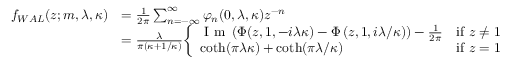Convert formula to latex. <formula><loc_0><loc_0><loc_500><loc_500>{ \begin{array} { r l } { f _ { W A L } ( z ; m , \lambda , \kappa ) } & { = { \frac { 1 } { 2 \pi } } \sum _ { n = - \infty } ^ { \infty } \varphi _ { n } ( 0 , \lambda , \kappa ) z ^ { - n } } \\ & { = { \frac { \lambda } { \pi ( \kappa + 1 / \kappa ) } } { \left \{ \begin{array} { l l } { { I m } \left ( \Phi ( z , 1 , - i \lambda \kappa ) - \Phi \left ( z , 1 , i \lambda / \kappa \right ) \right ) - { \frac { 1 } { 2 \pi } } } & { { i f } z \neq 1 } \\ { \coth ( \pi \lambda \kappa ) + \coth ( \pi \lambda / \kappa ) } & { { i f } z = 1 } \end{array} } } \end{array} }</formula> 